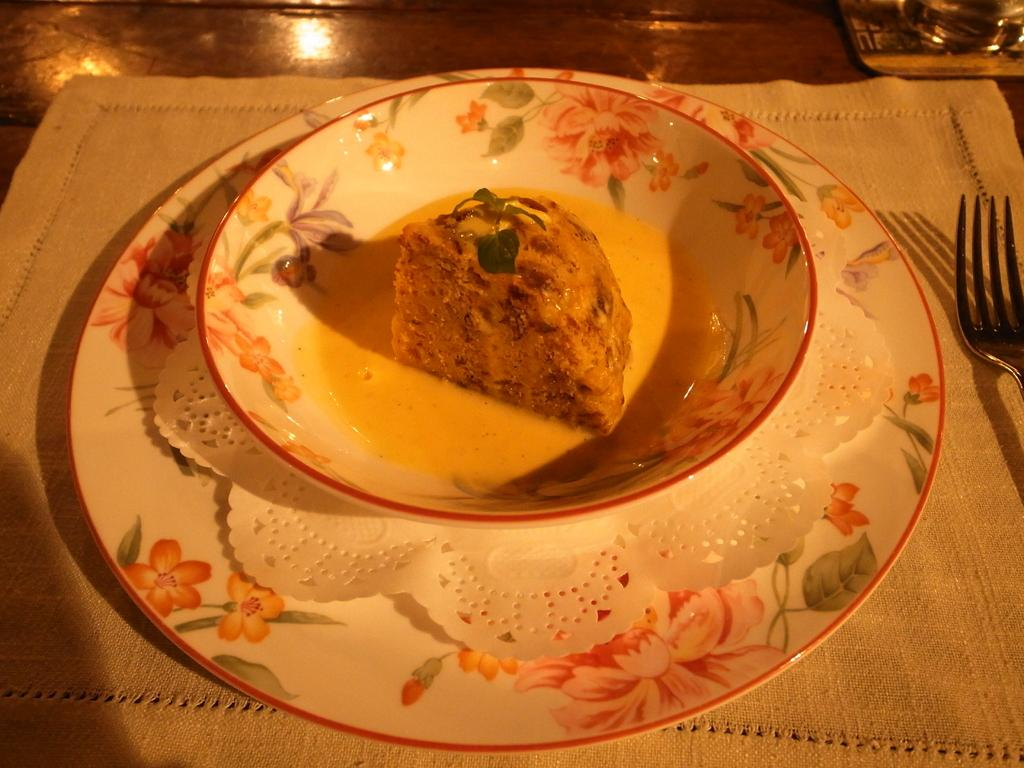What is the main food item in the image? There is a food item served in a bowl in the image. How is the bowl positioned in relation to the plate? The bowl is placed on a plate in the image. What utensil is located beside the plate? There is a fork beside the plate in the image. Can you hear the beetle crying in the image? There is no beetle present in the image, and therefore no sound or emotion can be attributed to it. 